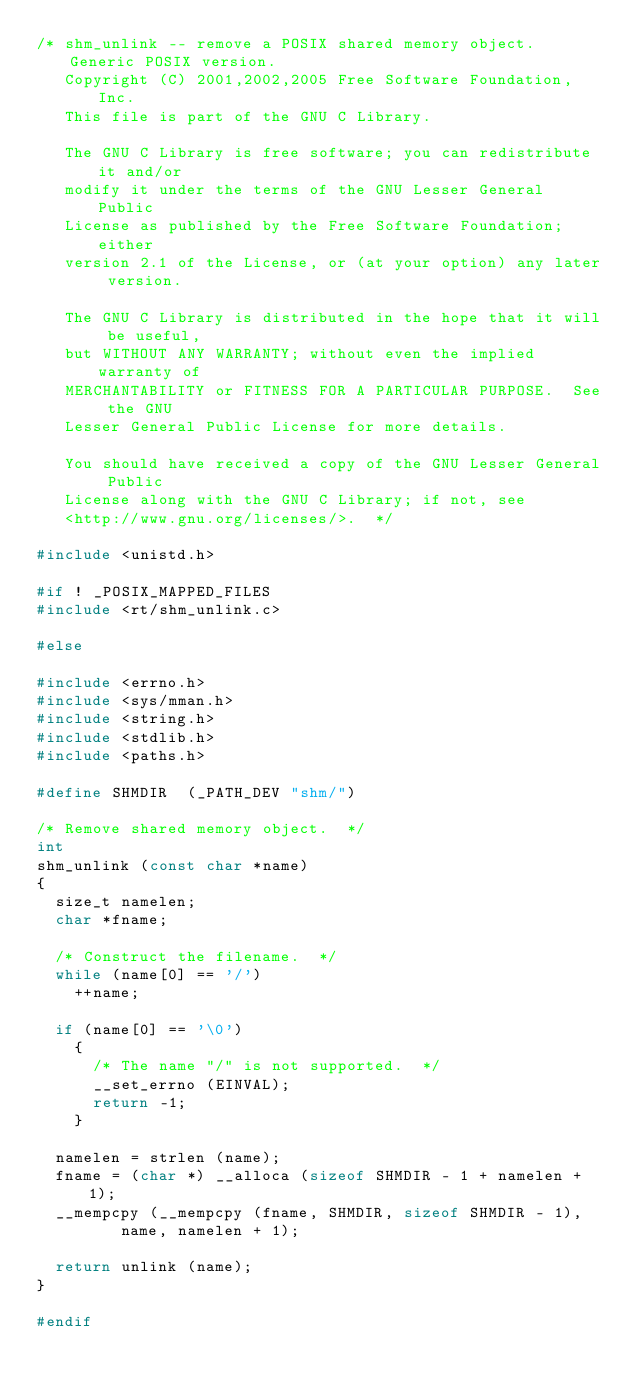<code> <loc_0><loc_0><loc_500><loc_500><_C_>/* shm_unlink -- remove a POSIX shared memory object.  Generic POSIX version.
   Copyright (C) 2001,2002,2005 Free Software Foundation, Inc.
   This file is part of the GNU C Library.

   The GNU C Library is free software; you can redistribute it and/or
   modify it under the terms of the GNU Lesser General Public
   License as published by the Free Software Foundation; either
   version 2.1 of the License, or (at your option) any later version.

   The GNU C Library is distributed in the hope that it will be useful,
   but WITHOUT ANY WARRANTY; without even the implied warranty of
   MERCHANTABILITY or FITNESS FOR A PARTICULAR PURPOSE.  See the GNU
   Lesser General Public License for more details.

   You should have received a copy of the GNU Lesser General Public
   License along with the GNU C Library; if not, see
   <http://www.gnu.org/licenses/>.  */

#include <unistd.h>

#if ! _POSIX_MAPPED_FILES
#include <rt/shm_unlink.c>

#else

#include <errno.h>
#include <sys/mman.h>
#include <string.h>
#include <stdlib.h>
#include <paths.h>

#define SHMDIR	(_PATH_DEV "shm/")

/* Remove shared memory object.  */
int
shm_unlink (const char *name)
{
  size_t namelen;
  char *fname;

  /* Construct the filename.  */
  while (name[0] == '/')
    ++name;

  if (name[0] == '\0')
    {
      /* The name "/" is not supported.  */
      __set_errno (EINVAL);
      return -1;
    }

  namelen = strlen (name);
  fname = (char *) __alloca (sizeof SHMDIR - 1 + namelen + 1);
  __mempcpy (__mempcpy (fname, SHMDIR, sizeof SHMDIR - 1),
	     name, namelen + 1);

  return unlink (name);
}

#endif
</code> 